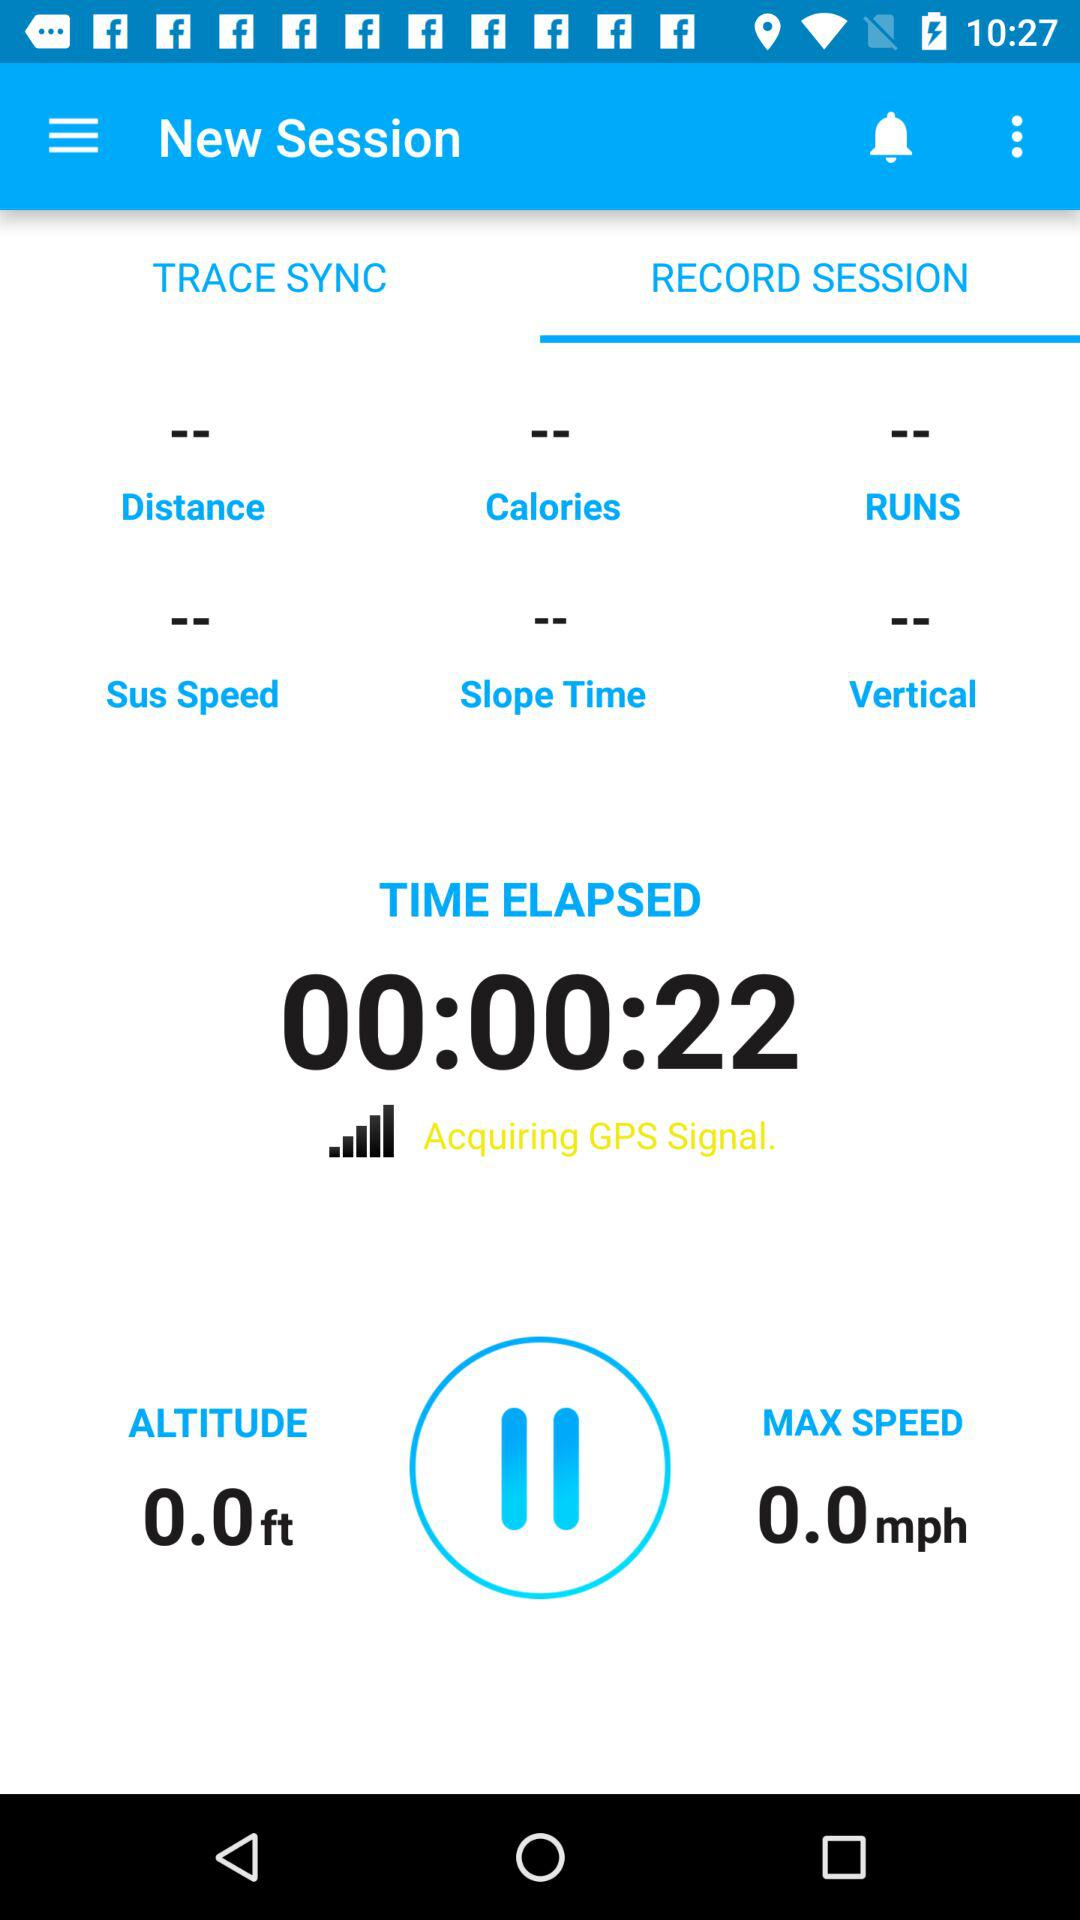How many seconds have elapsed since the start of the session?
Answer the question using a single word or phrase. 22 